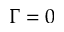<formula> <loc_0><loc_0><loc_500><loc_500>\Gamma = 0</formula> 